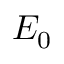<formula> <loc_0><loc_0><loc_500><loc_500>E _ { 0 }</formula> 